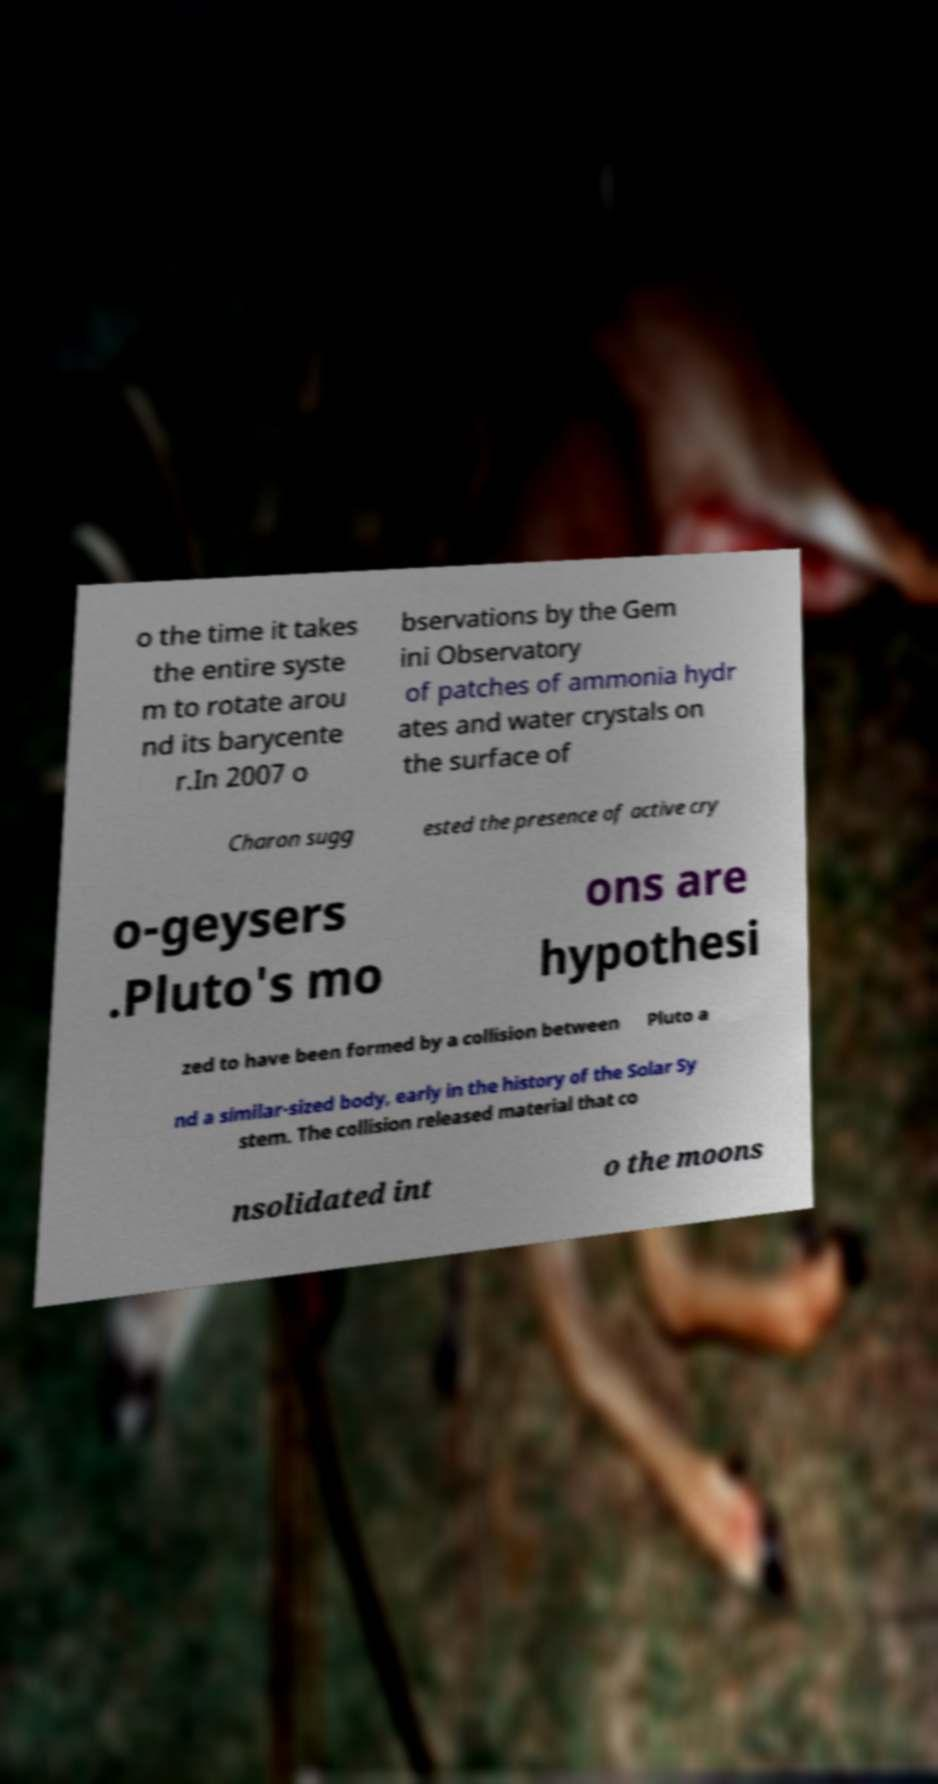Please read and relay the text visible in this image. What does it say? o the time it takes the entire syste m to rotate arou nd its barycente r.In 2007 o bservations by the Gem ini Observatory of patches of ammonia hydr ates and water crystals on the surface of Charon sugg ested the presence of active cry o-geysers .Pluto's mo ons are hypothesi zed to have been formed by a collision between Pluto a nd a similar-sized body, early in the history of the Solar Sy stem. The collision released material that co nsolidated int o the moons 